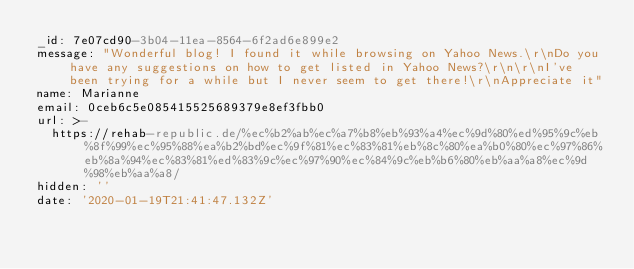<code> <loc_0><loc_0><loc_500><loc_500><_YAML_>_id: 7e07cd90-3b04-11ea-8564-6f2ad6e899e2
message: "Wonderful blog! I found it while browsing on Yahoo News.\r\nDo you have any suggestions on how to get listed in Yahoo News?\r\n\r\nI've been trying for a while but I never seem to get there!\r\nAppreciate it"
name: Marianne
email: 0ceb6c5e085415525689379e8ef3fbb0
url: >-
  https://rehab-republic.de/%ec%b2%ab%ec%a7%b8%eb%93%a4%ec%9d%80%ed%95%9c%eb%8f%99%ec%95%88%ea%b2%bd%ec%9f%81%ec%83%81%eb%8c%80%ea%b0%80%ec%97%86%eb%8a%94%ec%83%81%ed%83%9c%ec%97%90%ec%84%9c%eb%b6%80%eb%aa%a8%ec%9d%98%eb%aa%a8/
hidden: ''
date: '2020-01-19T21:41:47.132Z'
</code> 